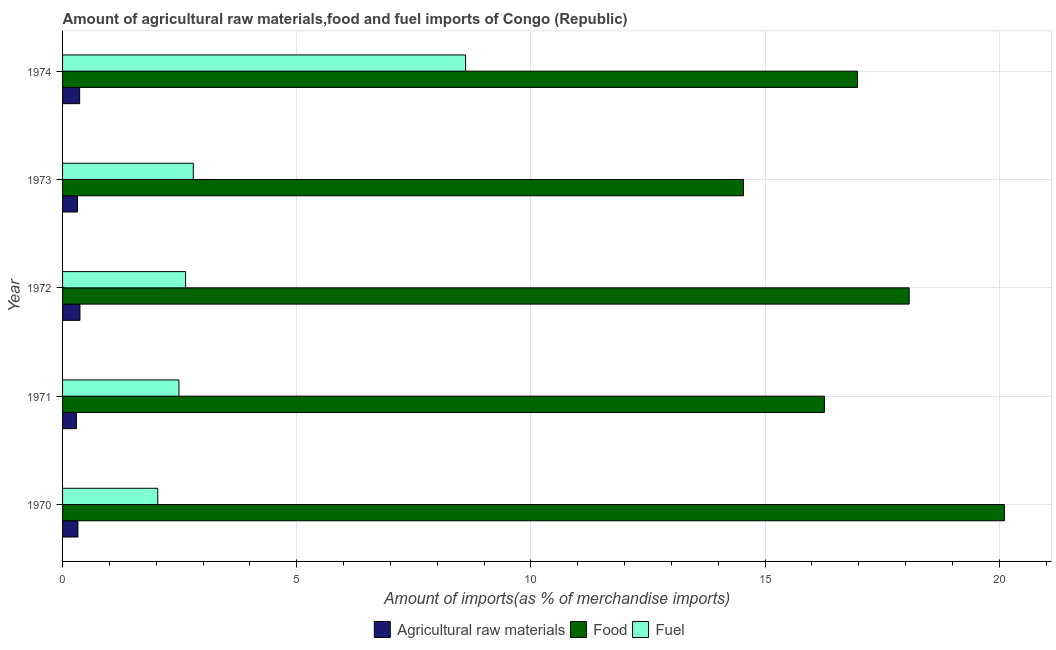How many groups of bars are there?
Your response must be concise. 5. Are the number of bars per tick equal to the number of legend labels?
Give a very brief answer. Yes. How many bars are there on the 4th tick from the bottom?
Your response must be concise. 3. What is the label of the 1st group of bars from the top?
Ensure brevity in your answer.  1974. What is the percentage of raw materials imports in 1971?
Your response must be concise. 0.3. Across all years, what is the maximum percentage of food imports?
Ensure brevity in your answer.  20.11. Across all years, what is the minimum percentage of food imports?
Your response must be concise. 14.54. In which year was the percentage of fuel imports maximum?
Make the answer very short. 1974. What is the total percentage of fuel imports in the graph?
Your response must be concise. 18.54. What is the difference between the percentage of raw materials imports in 1973 and that in 1974?
Ensure brevity in your answer.  -0.05. What is the difference between the percentage of food imports in 1974 and the percentage of raw materials imports in 1972?
Your response must be concise. 16.6. What is the average percentage of raw materials imports per year?
Offer a terse response. 0.34. In the year 1974, what is the difference between the percentage of food imports and percentage of fuel imports?
Provide a succinct answer. 8.37. What is the ratio of the percentage of raw materials imports in 1973 to that in 1974?
Provide a short and direct response. 0.87. Is the percentage of food imports in 1973 less than that in 1974?
Keep it short and to the point. Yes. Is the difference between the percentage of food imports in 1972 and 1974 greater than the difference between the percentage of raw materials imports in 1972 and 1974?
Keep it short and to the point. Yes. What is the difference between the highest and the second highest percentage of fuel imports?
Offer a terse response. 5.81. What is the difference between the highest and the lowest percentage of raw materials imports?
Offer a very short reply. 0.08. What does the 2nd bar from the top in 1974 represents?
Your response must be concise. Food. What does the 1st bar from the bottom in 1970 represents?
Give a very brief answer. Agricultural raw materials. Is it the case that in every year, the sum of the percentage of raw materials imports and percentage of food imports is greater than the percentage of fuel imports?
Provide a short and direct response. Yes. Are all the bars in the graph horizontal?
Your answer should be very brief. Yes. Does the graph contain any zero values?
Make the answer very short. No. How are the legend labels stacked?
Offer a terse response. Horizontal. What is the title of the graph?
Your answer should be compact. Amount of agricultural raw materials,food and fuel imports of Congo (Republic). Does "Capital account" appear as one of the legend labels in the graph?
Provide a short and direct response. No. What is the label or title of the X-axis?
Provide a succinct answer. Amount of imports(as % of merchandise imports). What is the label or title of the Y-axis?
Your answer should be very brief. Year. What is the Amount of imports(as % of merchandise imports) in Agricultural raw materials in 1970?
Offer a terse response. 0.33. What is the Amount of imports(as % of merchandise imports) of Food in 1970?
Your response must be concise. 20.11. What is the Amount of imports(as % of merchandise imports) of Fuel in 1970?
Keep it short and to the point. 2.03. What is the Amount of imports(as % of merchandise imports) in Agricultural raw materials in 1971?
Provide a short and direct response. 0.3. What is the Amount of imports(as % of merchandise imports) in Food in 1971?
Your answer should be very brief. 16.27. What is the Amount of imports(as % of merchandise imports) of Fuel in 1971?
Ensure brevity in your answer.  2.48. What is the Amount of imports(as % of merchandise imports) of Agricultural raw materials in 1972?
Provide a succinct answer. 0.37. What is the Amount of imports(as % of merchandise imports) in Food in 1972?
Provide a short and direct response. 18.08. What is the Amount of imports(as % of merchandise imports) in Fuel in 1972?
Provide a succinct answer. 2.63. What is the Amount of imports(as % of merchandise imports) in Agricultural raw materials in 1973?
Your response must be concise. 0.32. What is the Amount of imports(as % of merchandise imports) in Food in 1973?
Offer a terse response. 14.54. What is the Amount of imports(as % of merchandise imports) of Fuel in 1973?
Provide a succinct answer. 2.79. What is the Amount of imports(as % of merchandise imports) of Agricultural raw materials in 1974?
Offer a very short reply. 0.36. What is the Amount of imports(as % of merchandise imports) in Food in 1974?
Give a very brief answer. 16.97. What is the Amount of imports(as % of merchandise imports) in Fuel in 1974?
Give a very brief answer. 8.61. Across all years, what is the maximum Amount of imports(as % of merchandise imports) of Agricultural raw materials?
Offer a terse response. 0.37. Across all years, what is the maximum Amount of imports(as % of merchandise imports) in Food?
Your answer should be very brief. 20.11. Across all years, what is the maximum Amount of imports(as % of merchandise imports) in Fuel?
Offer a terse response. 8.61. Across all years, what is the minimum Amount of imports(as % of merchandise imports) of Agricultural raw materials?
Offer a terse response. 0.3. Across all years, what is the minimum Amount of imports(as % of merchandise imports) of Food?
Make the answer very short. 14.54. Across all years, what is the minimum Amount of imports(as % of merchandise imports) of Fuel?
Offer a very short reply. 2.03. What is the total Amount of imports(as % of merchandise imports) in Agricultural raw materials in the graph?
Offer a very short reply. 1.68. What is the total Amount of imports(as % of merchandise imports) in Food in the graph?
Your answer should be compact. 85.97. What is the total Amount of imports(as % of merchandise imports) of Fuel in the graph?
Offer a very short reply. 18.54. What is the difference between the Amount of imports(as % of merchandise imports) of Agricultural raw materials in 1970 and that in 1971?
Offer a very short reply. 0.03. What is the difference between the Amount of imports(as % of merchandise imports) of Food in 1970 and that in 1971?
Your answer should be very brief. 3.84. What is the difference between the Amount of imports(as % of merchandise imports) in Fuel in 1970 and that in 1971?
Offer a terse response. -0.45. What is the difference between the Amount of imports(as % of merchandise imports) of Agricultural raw materials in 1970 and that in 1972?
Provide a succinct answer. -0.04. What is the difference between the Amount of imports(as % of merchandise imports) of Food in 1970 and that in 1972?
Give a very brief answer. 2.03. What is the difference between the Amount of imports(as % of merchandise imports) of Fuel in 1970 and that in 1972?
Ensure brevity in your answer.  -0.59. What is the difference between the Amount of imports(as % of merchandise imports) in Agricultural raw materials in 1970 and that in 1973?
Keep it short and to the point. 0.01. What is the difference between the Amount of imports(as % of merchandise imports) in Food in 1970 and that in 1973?
Your answer should be compact. 5.57. What is the difference between the Amount of imports(as % of merchandise imports) in Fuel in 1970 and that in 1973?
Keep it short and to the point. -0.76. What is the difference between the Amount of imports(as % of merchandise imports) of Agricultural raw materials in 1970 and that in 1974?
Your response must be concise. -0.04. What is the difference between the Amount of imports(as % of merchandise imports) in Food in 1970 and that in 1974?
Your answer should be very brief. 3.14. What is the difference between the Amount of imports(as % of merchandise imports) in Fuel in 1970 and that in 1974?
Provide a short and direct response. -6.57. What is the difference between the Amount of imports(as % of merchandise imports) in Agricultural raw materials in 1971 and that in 1972?
Your answer should be very brief. -0.08. What is the difference between the Amount of imports(as % of merchandise imports) in Food in 1971 and that in 1972?
Offer a very short reply. -1.81. What is the difference between the Amount of imports(as % of merchandise imports) in Fuel in 1971 and that in 1972?
Keep it short and to the point. -0.14. What is the difference between the Amount of imports(as % of merchandise imports) in Agricultural raw materials in 1971 and that in 1973?
Offer a terse response. -0.02. What is the difference between the Amount of imports(as % of merchandise imports) in Food in 1971 and that in 1973?
Keep it short and to the point. 1.73. What is the difference between the Amount of imports(as % of merchandise imports) in Fuel in 1971 and that in 1973?
Offer a terse response. -0.31. What is the difference between the Amount of imports(as % of merchandise imports) in Agricultural raw materials in 1971 and that in 1974?
Your response must be concise. -0.07. What is the difference between the Amount of imports(as % of merchandise imports) of Food in 1971 and that in 1974?
Make the answer very short. -0.71. What is the difference between the Amount of imports(as % of merchandise imports) in Fuel in 1971 and that in 1974?
Make the answer very short. -6.12. What is the difference between the Amount of imports(as % of merchandise imports) in Agricultural raw materials in 1972 and that in 1973?
Provide a succinct answer. 0.05. What is the difference between the Amount of imports(as % of merchandise imports) in Food in 1972 and that in 1973?
Make the answer very short. 3.54. What is the difference between the Amount of imports(as % of merchandise imports) of Fuel in 1972 and that in 1973?
Your answer should be compact. -0.16. What is the difference between the Amount of imports(as % of merchandise imports) of Agricultural raw materials in 1972 and that in 1974?
Ensure brevity in your answer.  0.01. What is the difference between the Amount of imports(as % of merchandise imports) in Food in 1972 and that in 1974?
Keep it short and to the point. 1.1. What is the difference between the Amount of imports(as % of merchandise imports) of Fuel in 1972 and that in 1974?
Your answer should be very brief. -5.98. What is the difference between the Amount of imports(as % of merchandise imports) in Agricultural raw materials in 1973 and that in 1974?
Offer a very short reply. -0.05. What is the difference between the Amount of imports(as % of merchandise imports) in Food in 1973 and that in 1974?
Your answer should be compact. -2.44. What is the difference between the Amount of imports(as % of merchandise imports) of Fuel in 1973 and that in 1974?
Ensure brevity in your answer.  -5.81. What is the difference between the Amount of imports(as % of merchandise imports) of Agricultural raw materials in 1970 and the Amount of imports(as % of merchandise imports) of Food in 1971?
Make the answer very short. -15.94. What is the difference between the Amount of imports(as % of merchandise imports) in Agricultural raw materials in 1970 and the Amount of imports(as % of merchandise imports) in Fuel in 1971?
Make the answer very short. -2.16. What is the difference between the Amount of imports(as % of merchandise imports) in Food in 1970 and the Amount of imports(as % of merchandise imports) in Fuel in 1971?
Ensure brevity in your answer.  17.63. What is the difference between the Amount of imports(as % of merchandise imports) in Agricultural raw materials in 1970 and the Amount of imports(as % of merchandise imports) in Food in 1972?
Keep it short and to the point. -17.75. What is the difference between the Amount of imports(as % of merchandise imports) of Agricultural raw materials in 1970 and the Amount of imports(as % of merchandise imports) of Fuel in 1972?
Keep it short and to the point. -2.3. What is the difference between the Amount of imports(as % of merchandise imports) in Food in 1970 and the Amount of imports(as % of merchandise imports) in Fuel in 1972?
Provide a short and direct response. 17.48. What is the difference between the Amount of imports(as % of merchandise imports) in Agricultural raw materials in 1970 and the Amount of imports(as % of merchandise imports) in Food in 1973?
Your answer should be compact. -14.21. What is the difference between the Amount of imports(as % of merchandise imports) in Agricultural raw materials in 1970 and the Amount of imports(as % of merchandise imports) in Fuel in 1973?
Ensure brevity in your answer.  -2.46. What is the difference between the Amount of imports(as % of merchandise imports) in Food in 1970 and the Amount of imports(as % of merchandise imports) in Fuel in 1973?
Your answer should be compact. 17.32. What is the difference between the Amount of imports(as % of merchandise imports) of Agricultural raw materials in 1970 and the Amount of imports(as % of merchandise imports) of Food in 1974?
Give a very brief answer. -16.65. What is the difference between the Amount of imports(as % of merchandise imports) in Agricultural raw materials in 1970 and the Amount of imports(as % of merchandise imports) in Fuel in 1974?
Offer a very short reply. -8.28. What is the difference between the Amount of imports(as % of merchandise imports) in Food in 1970 and the Amount of imports(as % of merchandise imports) in Fuel in 1974?
Provide a succinct answer. 11.5. What is the difference between the Amount of imports(as % of merchandise imports) of Agricultural raw materials in 1971 and the Amount of imports(as % of merchandise imports) of Food in 1972?
Keep it short and to the point. -17.78. What is the difference between the Amount of imports(as % of merchandise imports) of Agricultural raw materials in 1971 and the Amount of imports(as % of merchandise imports) of Fuel in 1972?
Provide a short and direct response. -2.33. What is the difference between the Amount of imports(as % of merchandise imports) of Food in 1971 and the Amount of imports(as % of merchandise imports) of Fuel in 1972?
Your answer should be compact. 13.64. What is the difference between the Amount of imports(as % of merchandise imports) in Agricultural raw materials in 1971 and the Amount of imports(as % of merchandise imports) in Food in 1973?
Provide a succinct answer. -14.24. What is the difference between the Amount of imports(as % of merchandise imports) in Agricultural raw materials in 1971 and the Amount of imports(as % of merchandise imports) in Fuel in 1973?
Offer a terse response. -2.5. What is the difference between the Amount of imports(as % of merchandise imports) in Food in 1971 and the Amount of imports(as % of merchandise imports) in Fuel in 1973?
Your answer should be very brief. 13.48. What is the difference between the Amount of imports(as % of merchandise imports) in Agricultural raw materials in 1971 and the Amount of imports(as % of merchandise imports) in Food in 1974?
Keep it short and to the point. -16.68. What is the difference between the Amount of imports(as % of merchandise imports) in Agricultural raw materials in 1971 and the Amount of imports(as % of merchandise imports) in Fuel in 1974?
Your response must be concise. -8.31. What is the difference between the Amount of imports(as % of merchandise imports) in Food in 1971 and the Amount of imports(as % of merchandise imports) in Fuel in 1974?
Offer a very short reply. 7.66. What is the difference between the Amount of imports(as % of merchandise imports) of Agricultural raw materials in 1972 and the Amount of imports(as % of merchandise imports) of Food in 1973?
Your response must be concise. -14.17. What is the difference between the Amount of imports(as % of merchandise imports) in Agricultural raw materials in 1972 and the Amount of imports(as % of merchandise imports) in Fuel in 1973?
Provide a succinct answer. -2.42. What is the difference between the Amount of imports(as % of merchandise imports) in Food in 1972 and the Amount of imports(as % of merchandise imports) in Fuel in 1973?
Make the answer very short. 15.29. What is the difference between the Amount of imports(as % of merchandise imports) of Agricultural raw materials in 1972 and the Amount of imports(as % of merchandise imports) of Food in 1974?
Make the answer very short. -16.6. What is the difference between the Amount of imports(as % of merchandise imports) of Agricultural raw materials in 1972 and the Amount of imports(as % of merchandise imports) of Fuel in 1974?
Make the answer very short. -8.23. What is the difference between the Amount of imports(as % of merchandise imports) in Food in 1972 and the Amount of imports(as % of merchandise imports) in Fuel in 1974?
Your response must be concise. 9.47. What is the difference between the Amount of imports(as % of merchandise imports) in Agricultural raw materials in 1973 and the Amount of imports(as % of merchandise imports) in Food in 1974?
Give a very brief answer. -16.66. What is the difference between the Amount of imports(as % of merchandise imports) in Agricultural raw materials in 1973 and the Amount of imports(as % of merchandise imports) in Fuel in 1974?
Ensure brevity in your answer.  -8.29. What is the difference between the Amount of imports(as % of merchandise imports) of Food in 1973 and the Amount of imports(as % of merchandise imports) of Fuel in 1974?
Provide a succinct answer. 5.93. What is the average Amount of imports(as % of merchandise imports) of Agricultural raw materials per year?
Make the answer very short. 0.34. What is the average Amount of imports(as % of merchandise imports) in Food per year?
Make the answer very short. 17.19. What is the average Amount of imports(as % of merchandise imports) in Fuel per year?
Provide a succinct answer. 3.71. In the year 1970, what is the difference between the Amount of imports(as % of merchandise imports) of Agricultural raw materials and Amount of imports(as % of merchandise imports) of Food?
Give a very brief answer. -19.78. In the year 1970, what is the difference between the Amount of imports(as % of merchandise imports) in Agricultural raw materials and Amount of imports(as % of merchandise imports) in Fuel?
Ensure brevity in your answer.  -1.7. In the year 1970, what is the difference between the Amount of imports(as % of merchandise imports) in Food and Amount of imports(as % of merchandise imports) in Fuel?
Ensure brevity in your answer.  18.08. In the year 1971, what is the difference between the Amount of imports(as % of merchandise imports) of Agricultural raw materials and Amount of imports(as % of merchandise imports) of Food?
Give a very brief answer. -15.97. In the year 1971, what is the difference between the Amount of imports(as % of merchandise imports) of Agricultural raw materials and Amount of imports(as % of merchandise imports) of Fuel?
Provide a short and direct response. -2.19. In the year 1971, what is the difference between the Amount of imports(as % of merchandise imports) in Food and Amount of imports(as % of merchandise imports) in Fuel?
Keep it short and to the point. 13.78. In the year 1972, what is the difference between the Amount of imports(as % of merchandise imports) of Agricultural raw materials and Amount of imports(as % of merchandise imports) of Food?
Offer a very short reply. -17.71. In the year 1972, what is the difference between the Amount of imports(as % of merchandise imports) of Agricultural raw materials and Amount of imports(as % of merchandise imports) of Fuel?
Your answer should be compact. -2.26. In the year 1972, what is the difference between the Amount of imports(as % of merchandise imports) in Food and Amount of imports(as % of merchandise imports) in Fuel?
Your answer should be very brief. 15.45. In the year 1973, what is the difference between the Amount of imports(as % of merchandise imports) of Agricultural raw materials and Amount of imports(as % of merchandise imports) of Food?
Ensure brevity in your answer.  -14.22. In the year 1973, what is the difference between the Amount of imports(as % of merchandise imports) of Agricultural raw materials and Amount of imports(as % of merchandise imports) of Fuel?
Your answer should be compact. -2.47. In the year 1973, what is the difference between the Amount of imports(as % of merchandise imports) of Food and Amount of imports(as % of merchandise imports) of Fuel?
Provide a short and direct response. 11.75. In the year 1974, what is the difference between the Amount of imports(as % of merchandise imports) in Agricultural raw materials and Amount of imports(as % of merchandise imports) in Food?
Make the answer very short. -16.61. In the year 1974, what is the difference between the Amount of imports(as % of merchandise imports) in Agricultural raw materials and Amount of imports(as % of merchandise imports) in Fuel?
Ensure brevity in your answer.  -8.24. In the year 1974, what is the difference between the Amount of imports(as % of merchandise imports) of Food and Amount of imports(as % of merchandise imports) of Fuel?
Give a very brief answer. 8.37. What is the ratio of the Amount of imports(as % of merchandise imports) of Agricultural raw materials in 1970 to that in 1971?
Your answer should be very brief. 1.11. What is the ratio of the Amount of imports(as % of merchandise imports) in Food in 1970 to that in 1971?
Give a very brief answer. 1.24. What is the ratio of the Amount of imports(as % of merchandise imports) in Fuel in 1970 to that in 1971?
Give a very brief answer. 0.82. What is the ratio of the Amount of imports(as % of merchandise imports) of Agricultural raw materials in 1970 to that in 1972?
Your answer should be compact. 0.88. What is the ratio of the Amount of imports(as % of merchandise imports) in Food in 1970 to that in 1972?
Your answer should be compact. 1.11. What is the ratio of the Amount of imports(as % of merchandise imports) of Fuel in 1970 to that in 1972?
Make the answer very short. 0.77. What is the ratio of the Amount of imports(as % of merchandise imports) in Agricultural raw materials in 1970 to that in 1973?
Ensure brevity in your answer.  1.03. What is the ratio of the Amount of imports(as % of merchandise imports) of Food in 1970 to that in 1973?
Keep it short and to the point. 1.38. What is the ratio of the Amount of imports(as % of merchandise imports) of Fuel in 1970 to that in 1973?
Your response must be concise. 0.73. What is the ratio of the Amount of imports(as % of merchandise imports) in Agricultural raw materials in 1970 to that in 1974?
Provide a succinct answer. 0.9. What is the ratio of the Amount of imports(as % of merchandise imports) in Food in 1970 to that in 1974?
Your answer should be compact. 1.18. What is the ratio of the Amount of imports(as % of merchandise imports) of Fuel in 1970 to that in 1974?
Offer a terse response. 0.24. What is the ratio of the Amount of imports(as % of merchandise imports) in Agricultural raw materials in 1971 to that in 1972?
Your response must be concise. 0.8. What is the ratio of the Amount of imports(as % of merchandise imports) in Food in 1971 to that in 1972?
Keep it short and to the point. 0.9. What is the ratio of the Amount of imports(as % of merchandise imports) of Fuel in 1971 to that in 1972?
Offer a terse response. 0.95. What is the ratio of the Amount of imports(as % of merchandise imports) of Agricultural raw materials in 1971 to that in 1973?
Make the answer very short. 0.93. What is the ratio of the Amount of imports(as % of merchandise imports) in Food in 1971 to that in 1973?
Offer a very short reply. 1.12. What is the ratio of the Amount of imports(as % of merchandise imports) of Fuel in 1971 to that in 1973?
Ensure brevity in your answer.  0.89. What is the ratio of the Amount of imports(as % of merchandise imports) in Agricultural raw materials in 1971 to that in 1974?
Provide a short and direct response. 0.81. What is the ratio of the Amount of imports(as % of merchandise imports) in Fuel in 1971 to that in 1974?
Offer a terse response. 0.29. What is the ratio of the Amount of imports(as % of merchandise imports) in Agricultural raw materials in 1972 to that in 1973?
Offer a terse response. 1.17. What is the ratio of the Amount of imports(as % of merchandise imports) in Food in 1972 to that in 1973?
Offer a very short reply. 1.24. What is the ratio of the Amount of imports(as % of merchandise imports) in Fuel in 1972 to that in 1973?
Your response must be concise. 0.94. What is the ratio of the Amount of imports(as % of merchandise imports) in Agricultural raw materials in 1972 to that in 1974?
Your answer should be very brief. 1.02. What is the ratio of the Amount of imports(as % of merchandise imports) of Food in 1972 to that in 1974?
Provide a succinct answer. 1.06. What is the ratio of the Amount of imports(as % of merchandise imports) in Fuel in 1972 to that in 1974?
Provide a short and direct response. 0.31. What is the ratio of the Amount of imports(as % of merchandise imports) in Agricultural raw materials in 1973 to that in 1974?
Your response must be concise. 0.87. What is the ratio of the Amount of imports(as % of merchandise imports) in Food in 1973 to that in 1974?
Offer a very short reply. 0.86. What is the ratio of the Amount of imports(as % of merchandise imports) of Fuel in 1973 to that in 1974?
Keep it short and to the point. 0.32. What is the difference between the highest and the second highest Amount of imports(as % of merchandise imports) of Agricultural raw materials?
Offer a very short reply. 0.01. What is the difference between the highest and the second highest Amount of imports(as % of merchandise imports) of Food?
Your response must be concise. 2.03. What is the difference between the highest and the second highest Amount of imports(as % of merchandise imports) of Fuel?
Your answer should be compact. 5.81. What is the difference between the highest and the lowest Amount of imports(as % of merchandise imports) in Agricultural raw materials?
Your answer should be compact. 0.08. What is the difference between the highest and the lowest Amount of imports(as % of merchandise imports) in Food?
Give a very brief answer. 5.57. What is the difference between the highest and the lowest Amount of imports(as % of merchandise imports) of Fuel?
Make the answer very short. 6.57. 